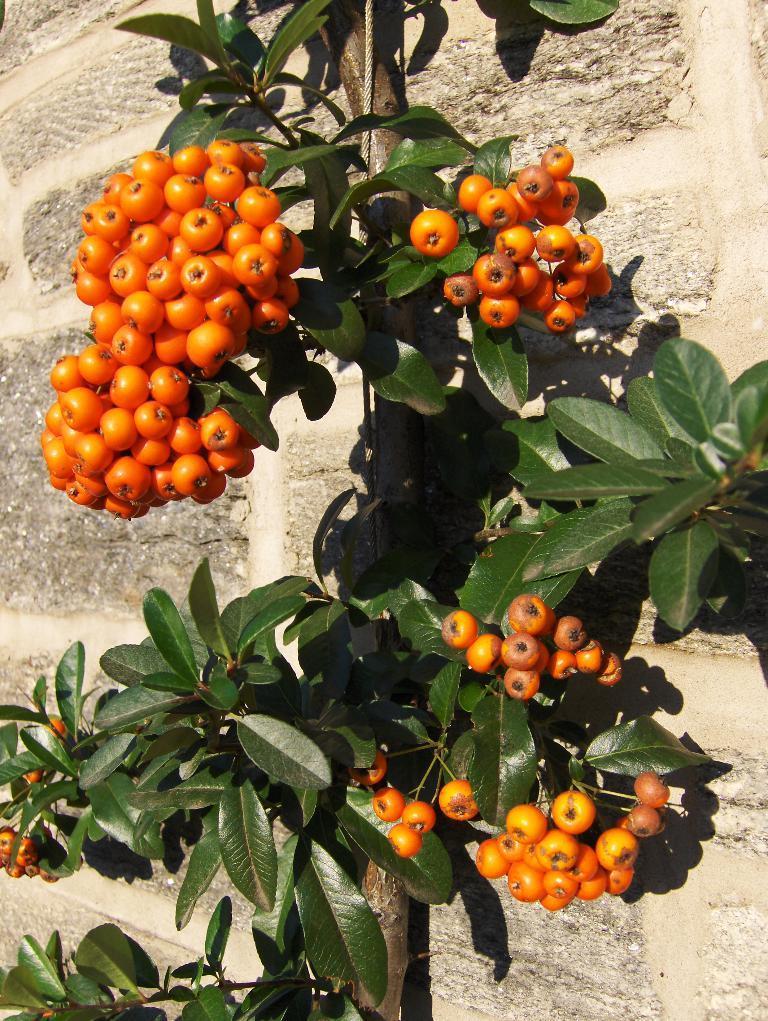Describe this image in one or two sentences. In the center of the image there is a tree and we can see fruits to the tree. In the background there is a wall. 